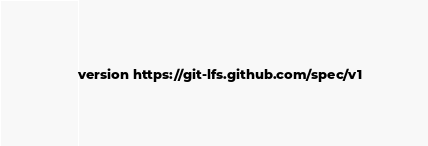Convert code to text. <code><loc_0><loc_0><loc_500><loc_500><_HTML_>version https://git-lfs.github.com/spec/v1</code> 